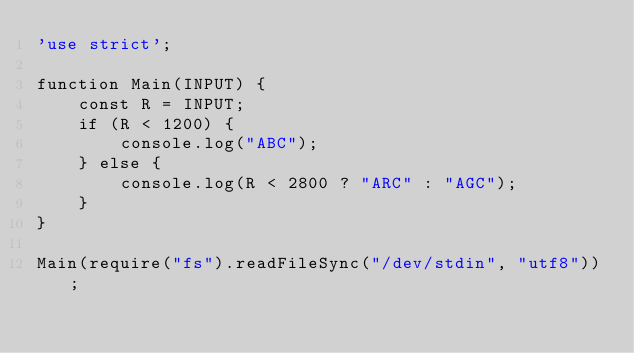<code> <loc_0><loc_0><loc_500><loc_500><_JavaScript_>'use strict';

function Main(INPUT) {
    const R = INPUT;
    if (R < 1200) {
        console.log("ABC");
    } else {
        console.log(R < 2800 ? "ARC" : "AGC");
    }
}

Main(require("fs").readFileSync("/dev/stdin", "utf8"));
</code> 